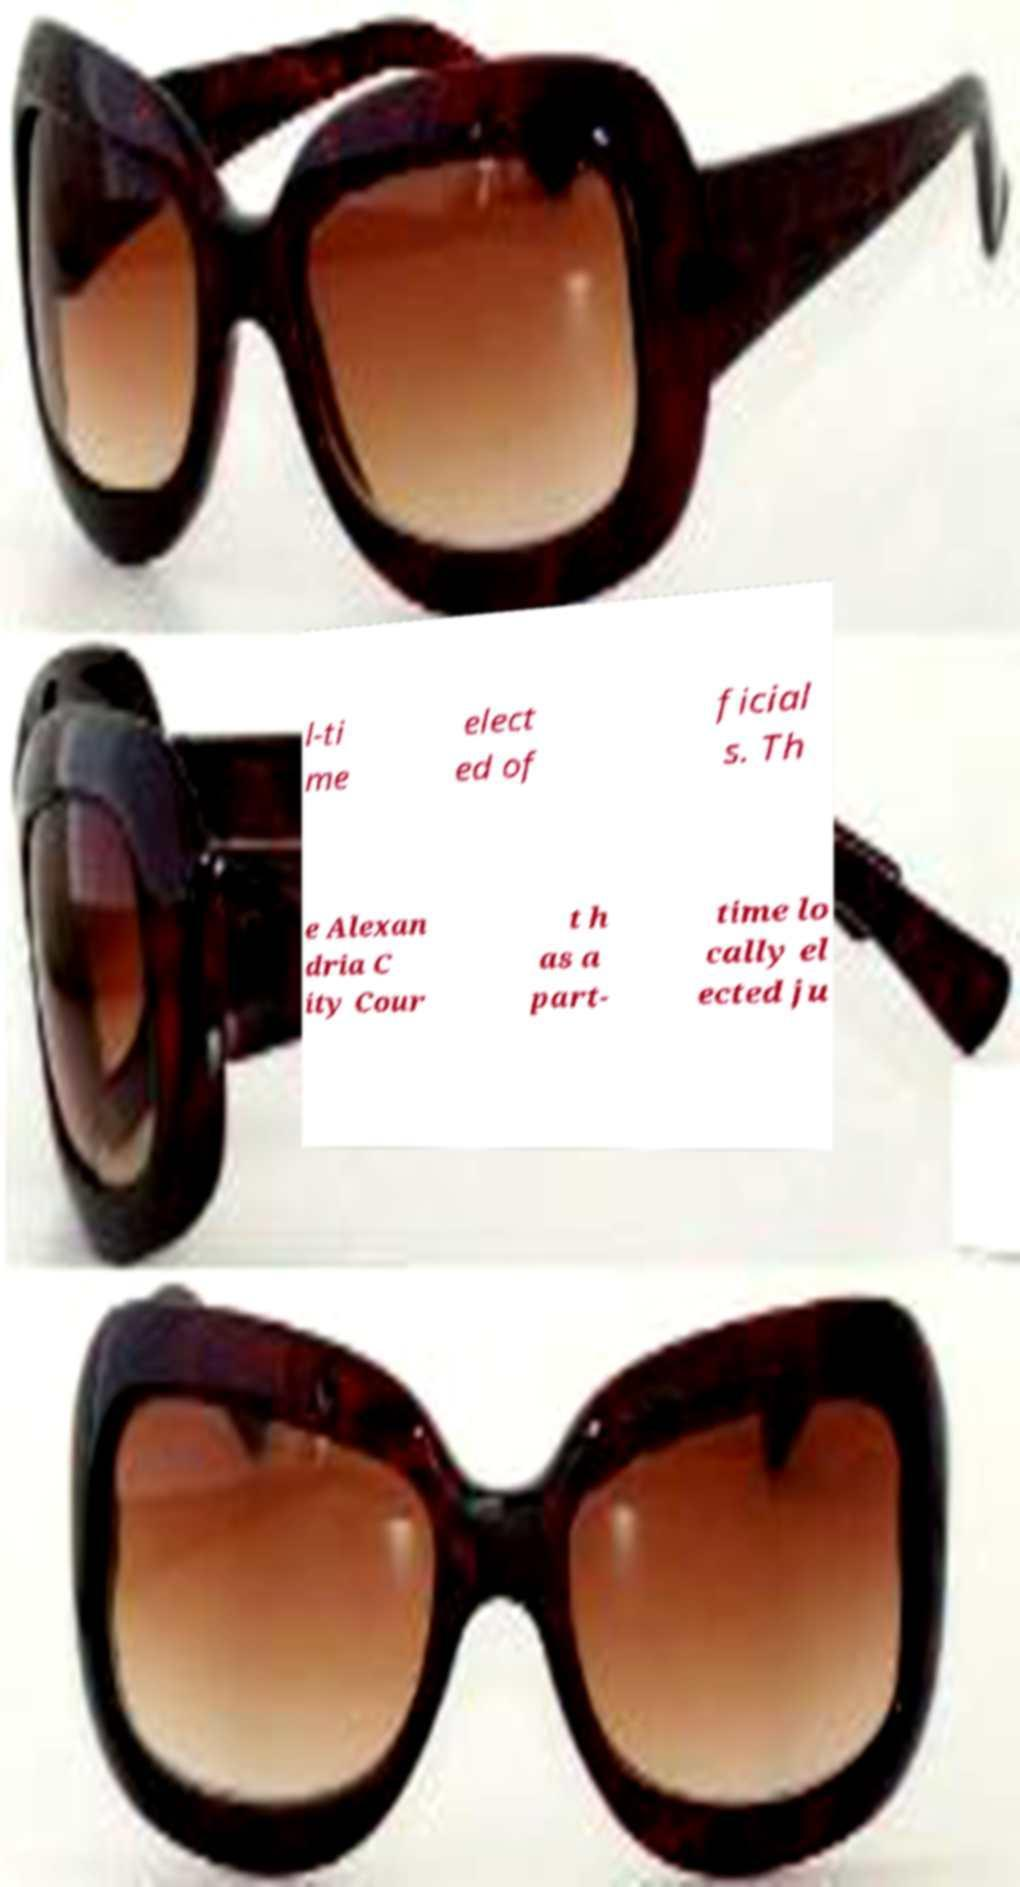Can you accurately transcribe the text from the provided image for me? l-ti me elect ed of ficial s. Th e Alexan dria C ity Cour t h as a part- time lo cally el ected ju 